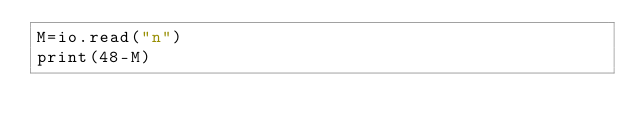Convert code to text. <code><loc_0><loc_0><loc_500><loc_500><_Lua_>M=io.read("n")
print(48-M)</code> 